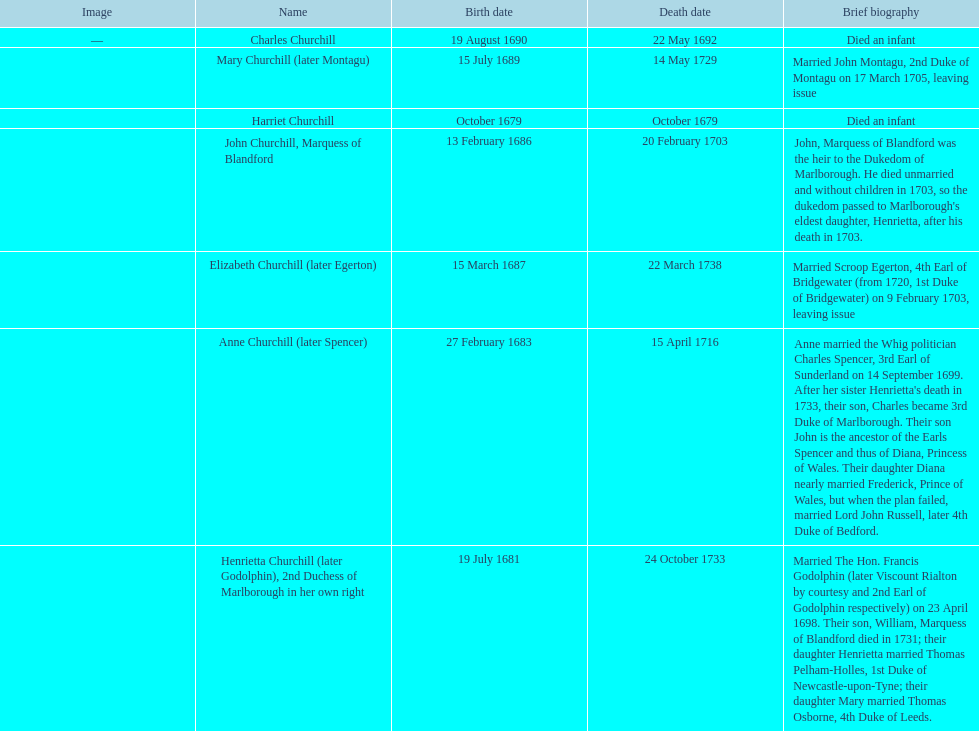Who was born first? mary churchill or elizabeth churchill? Elizabeth Churchill. 